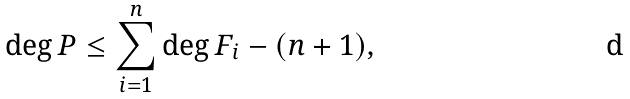<formula> <loc_0><loc_0><loc_500><loc_500>\deg P \leq \sum _ { i = 1 } ^ { n } \deg F _ { i } - ( n + 1 ) ,</formula> 